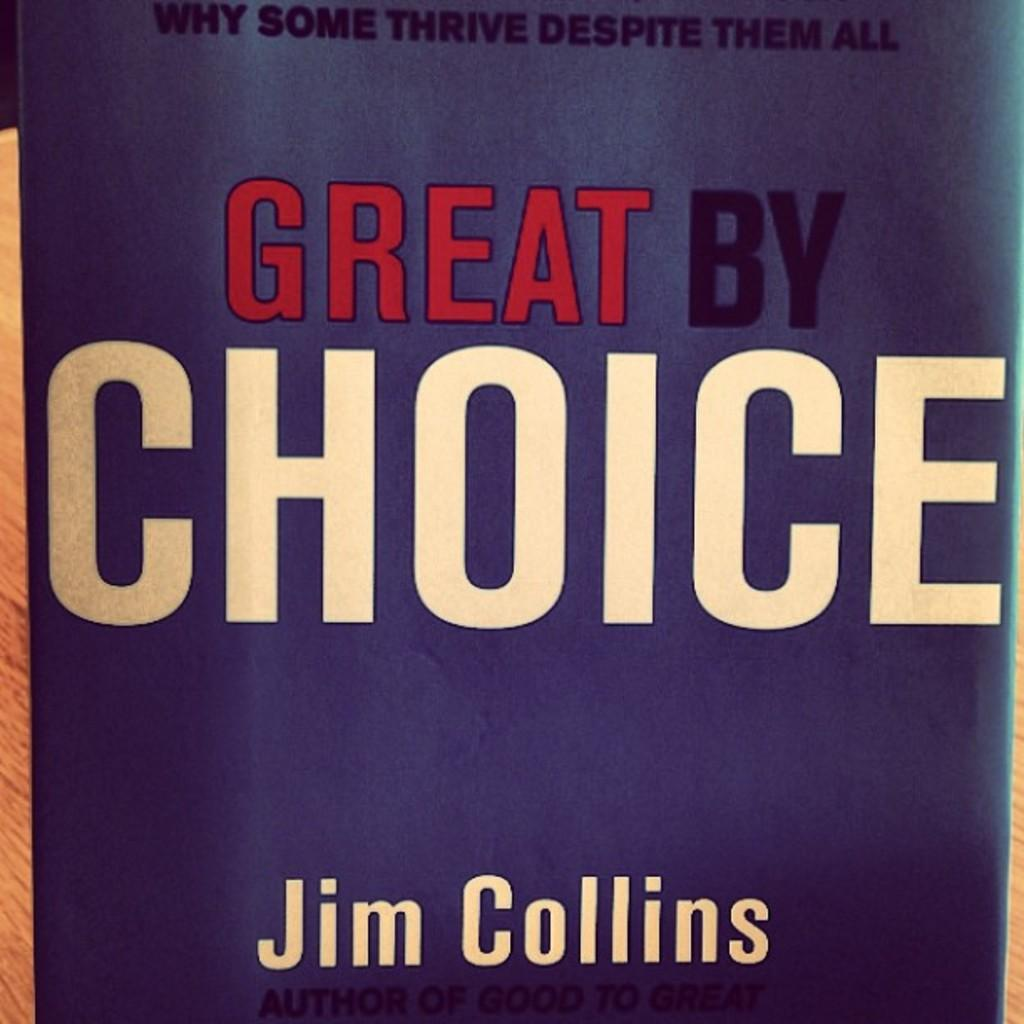<image>
Present a compact description of the photo's key features. Cover of a book by Jim Collins titled "Great By Choice" 